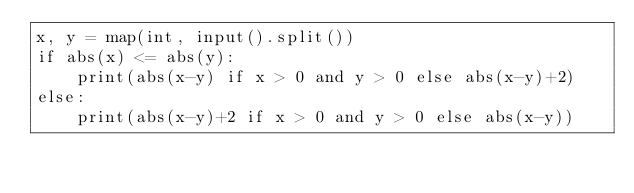Convert code to text. <code><loc_0><loc_0><loc_500><loc_500><_Python_>x, y = map(int, input().split())
if abs(x) <= abs(y):
    print(abs(x-y) if x > 0 and y > 0 else abs(x-y)+2)
else:
    print(abs(x-y)+2 if x > 0 and y > 0 else abs(x-y))
</code> 